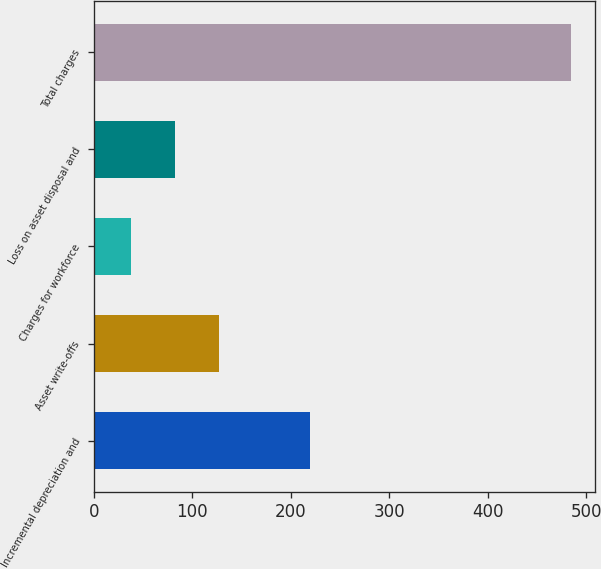Convert chart to OTSL. <chart><loc_0><loc_0><loc_500><loc_500><bar_chart><fcel>Incremental depreciation and<fcel>Asset write-offs<fcel>Charges for workforce<fcel>Loss on asset disposal and<fcel>Total charges<nl><fcel>219.65<fcel>127.2<fcel>37.9<fcel>82.55<fcel>484.4<nl></chart> 